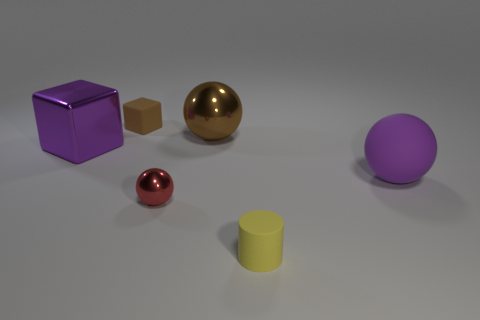Add 3 small metal spheres. How many objects exist? 9 Subtract all cylinders. How many objects are left? 5 Subtract 0 red cubes. How many objects are left? 6 Subtract all tiny spheres. Subtract all big purple metal blocks. How many objects are left? 4 Add 5 rubber objects. How many rubber objects are left? 8 Add 1 rubber blocks. How many rubber blocks exist? 2 